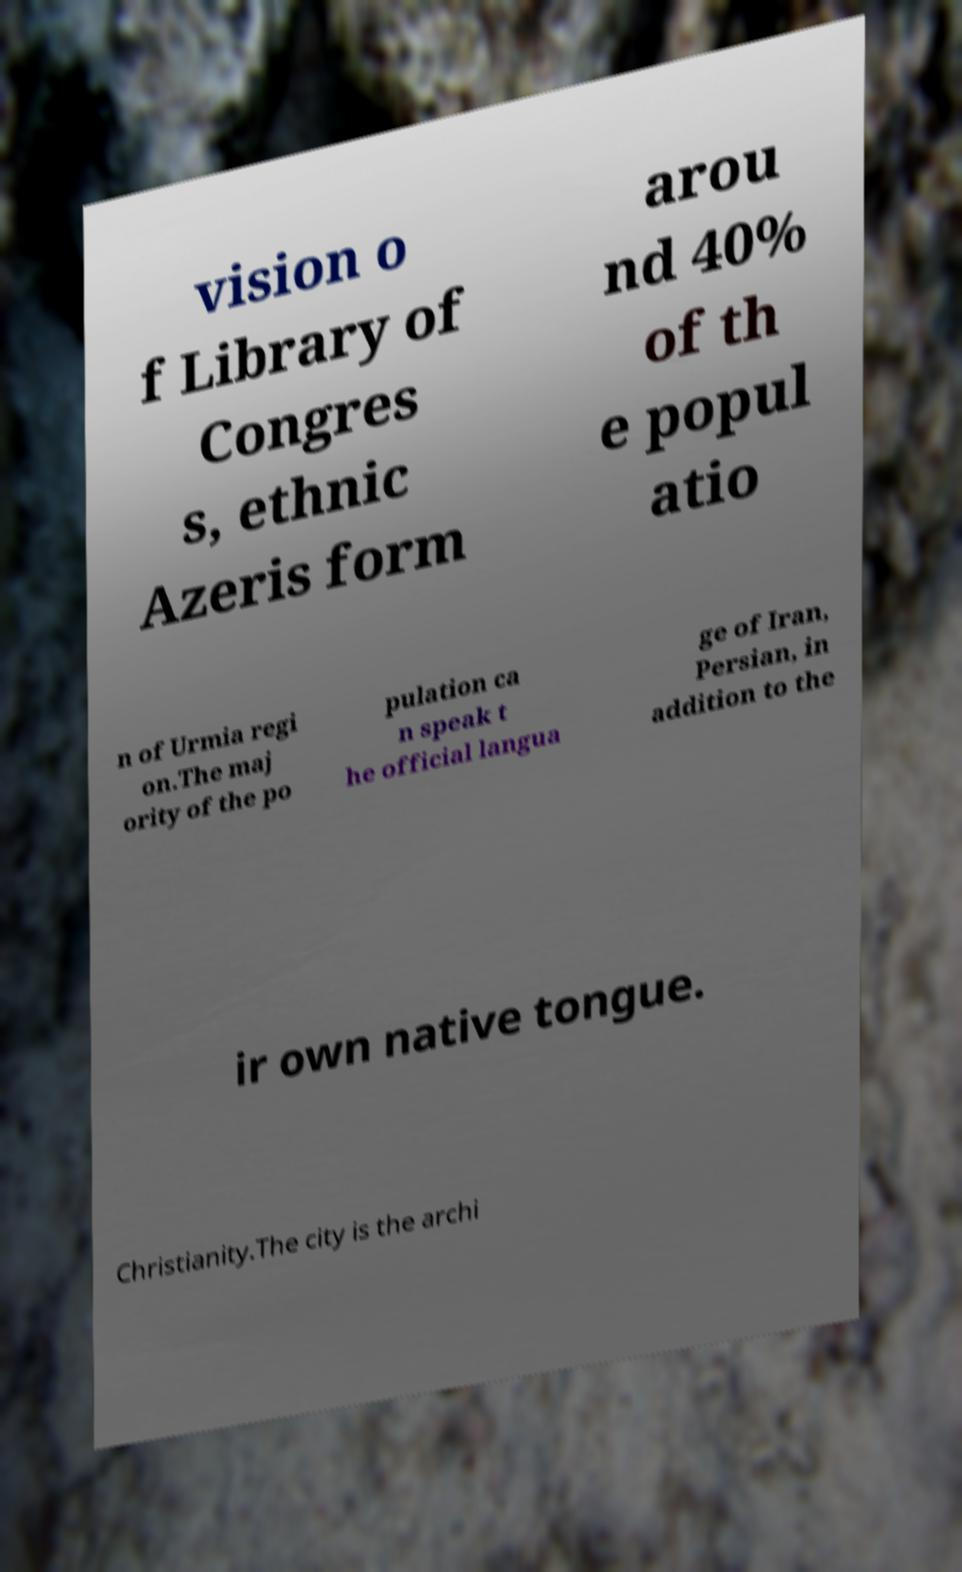Please identify and transcribe the text found in this image. vision o f Library of Congres s, ethnic Azeris form arou nd 40% of th e popul atio n of Urmia regi on.The maj ority of the po pulation ca n speak t he official langua ge of Iran, Persian, in addition to the ir own native tongue. Christianity.The city is the archi 